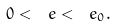Convert formula to latex. <formula><loc_0><loc_0><loc_500><loc_500>0 < \ e < \ e _ { 0 } .</formula> 